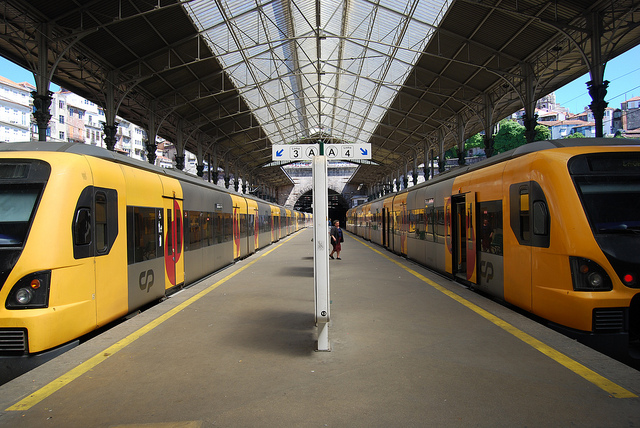Identify and read out the text in this image. 3 A A 4 